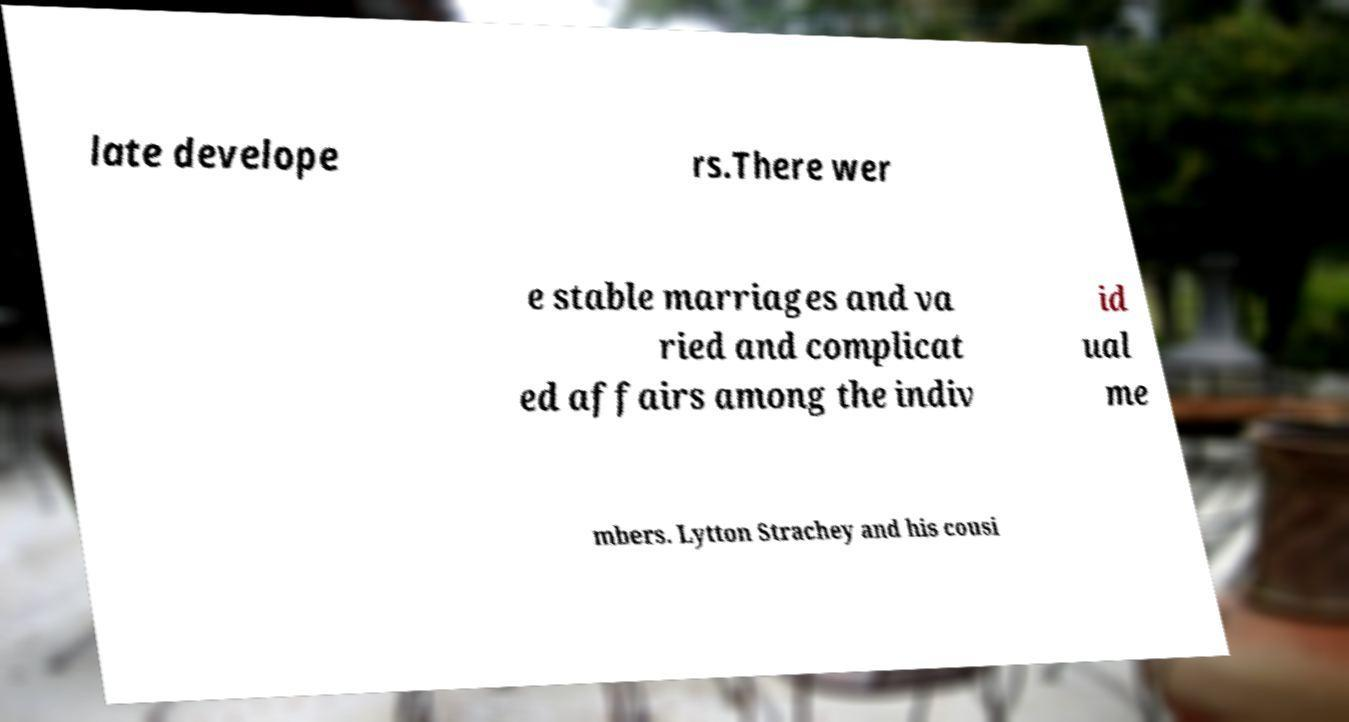Please identify and transcribe the text found in this image. late develope rs.There wer e stable marriages and va ried and complicat ed affairs among the indiv id ual me mbers. Lytton Strachey and his cousi 